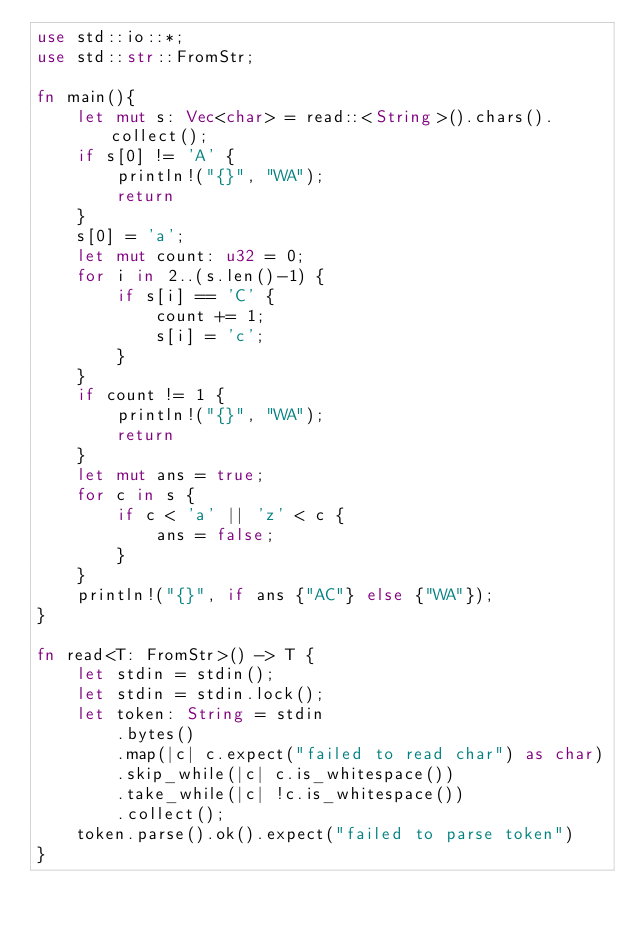<code> <loc_0><loc_0><loc_500><loc_500><_Rust_>use std::io::*;
use std::str::FromStr;

fn main(){
    let mut s: Vec<char> = read::<String>().chars().collect();
    if s[0] != 'A' {
        println!("{}", "WA");
        return
    }
    s[0] = 'a';
    let mut count: u32 = 0;
    for i in 2..(s.len()-1) {
        if s[i] == 'C' {
            count += 1;
            s[i] = 'c';
        }
    }
    if count != 1 {
        println!("{}", "WA");
        return
    }
    let mut ans = true;
    for c in s {
        if c < 'a' || 'z' < c {
            ans = false;
        }
    }
    println!("{}", if ans {"AC"} else {"WA"});
}

fn read<T: FromStr>() -> T {
    let stdin = stdin();
    let stdin = stdin.lock();
    let token: String = stdin
        .bytes()
        .map(|c| c.expect("failed to read char") as char) 
        .skip_while(|c| c.is_whitespace())
        .take_while(|c| !c.is_whitespace())
        .collect();
    token.parse().ok().expect("failed to parse token")
}</code> 